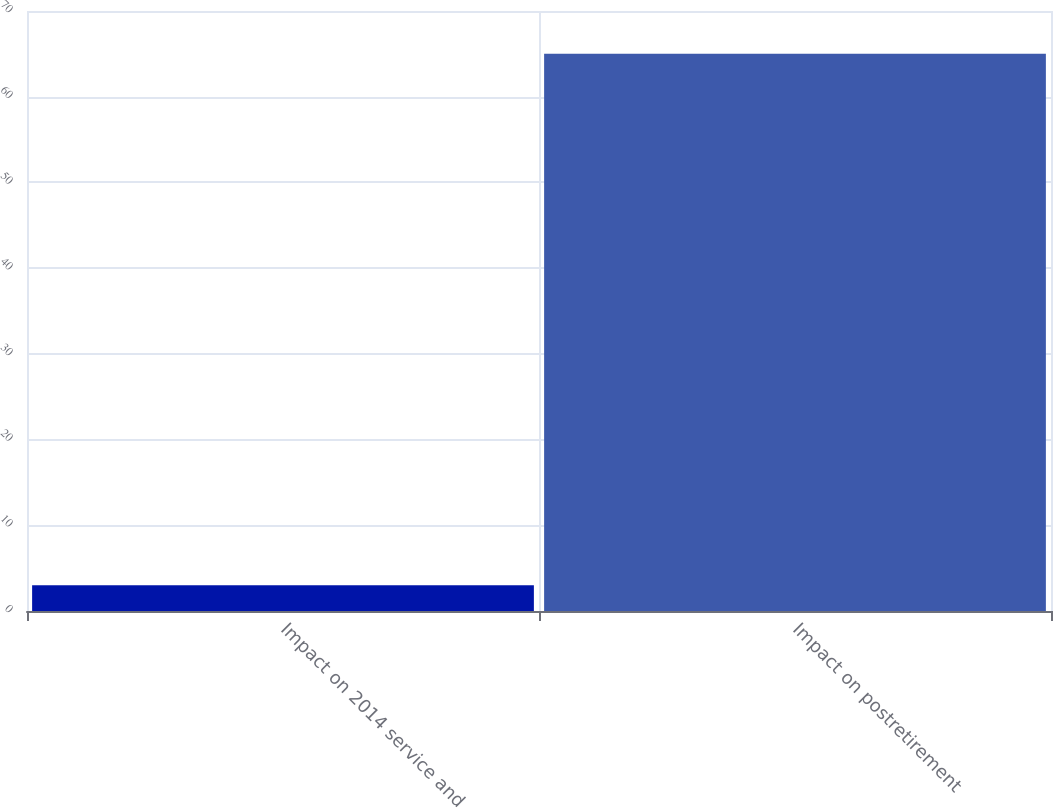Convert chart to OTSL. <chart><loc_0><loc_0><loc_500><loc_500><bar_chart><fcel>Impact on 2014 service and<fcel>Impact on postretirement<nl><fcel>3<fcel>65<nl></chart> 